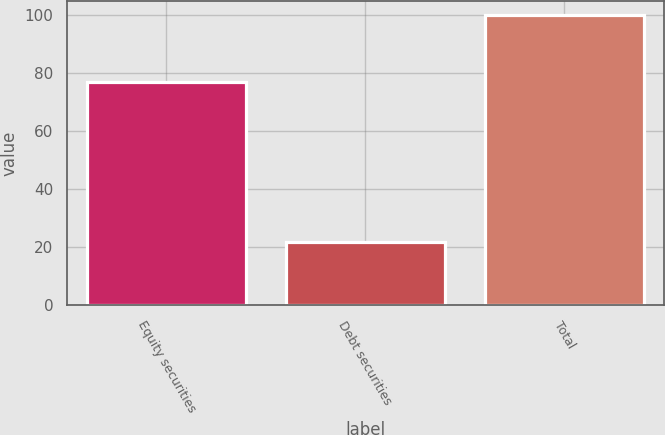<chart> <loc_0><loc_0><loc_500><loc_500><bar_chart><fcel>Equity securities<fcel>Debt securities<fcel>Total<nl><fcel>77<fcel>22<fcel>100<nl></chart> 